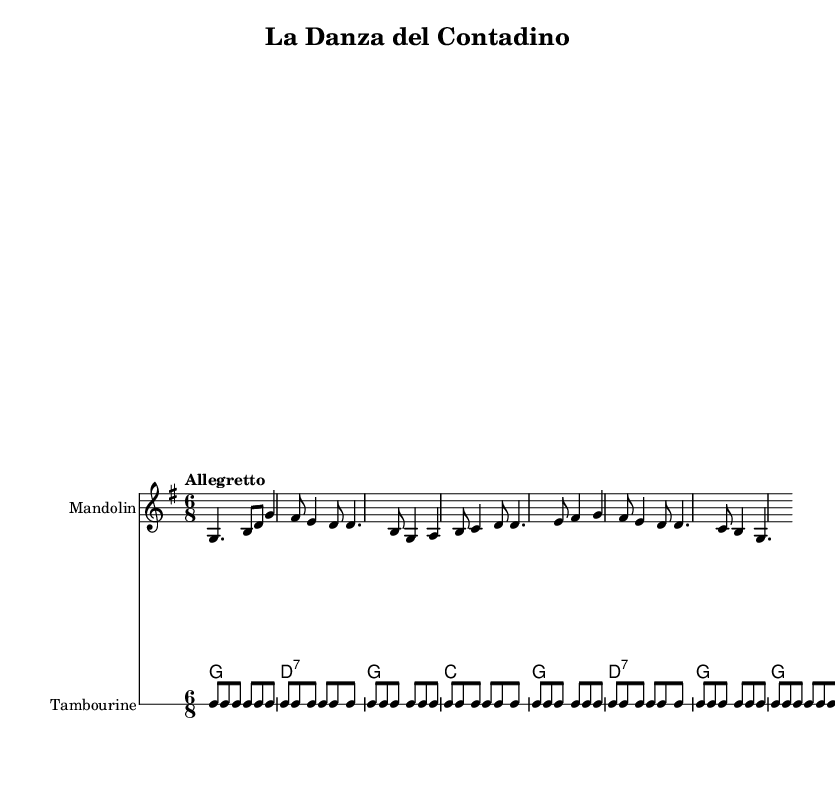What is the key signature of this music? The key signature is G major, which has one sharp (F#). This is indicated at the beginning of the sheet music.
Answer: G major What is the time signature of this music? The time signature is 6/8, as seen at the beginning of the score. This means there are six eighth notes per measure.
Answer: 6/8 What is the tempo marking for this piece? The tempo marking is "Allegretto," which suggests a moderately fast pace. This is indicated above the staff in the score.
Answer: Allegretto How many measures are in the melody? The melody consists of 8 measures as counted from the beginning to the end of the melody section.
Answer: 8 What instruments are used in this arrangement? The arrangement includes Mandolin, Guitar, and Tambourine as indicated by the names above the respective staves.
Answer: Mandolin, Guitar, Tambourine What is the main theme of the lyrics? The lyrics express joy and celebration, highlighting the experience of dancing in a social gathering. This can be inferred from phrases like "La tua vita è una gran festa!" which translates to "Your life is a great party!"
Answer: Celebration 